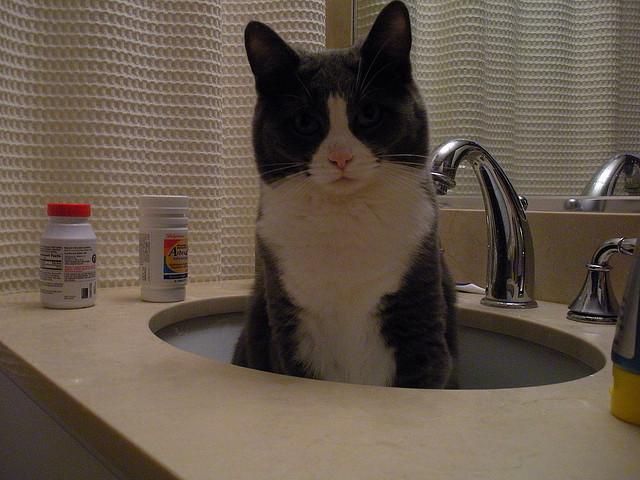Is the cat in the sink?
Quick response, please. Yes. Is this cat wearing a bowtie?
Short answer required. No. Where is the bottle of vitamins?
Concise answer only. On counter. What is the cat doing?
Quick response, please. Sitting in sink. 